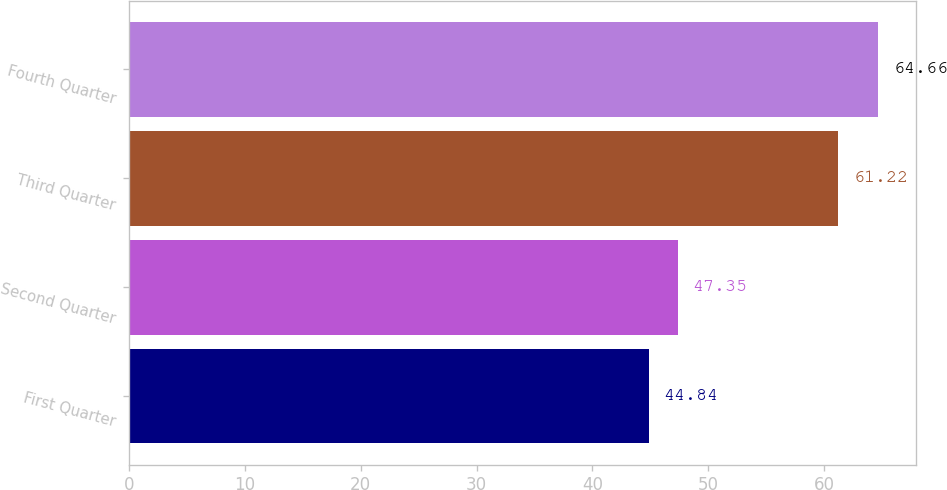<chart> <loc_0><loc_0><loc_500><loc_500><bar_chart><fcel>First Quarter<fcel>Second Quarter<fcel>Third Quarter<fcel>Fourth Quarter<nl><fcel>44.84<fcel>47.35<fcel>61.22<fcel>64.66<nl></chart> 